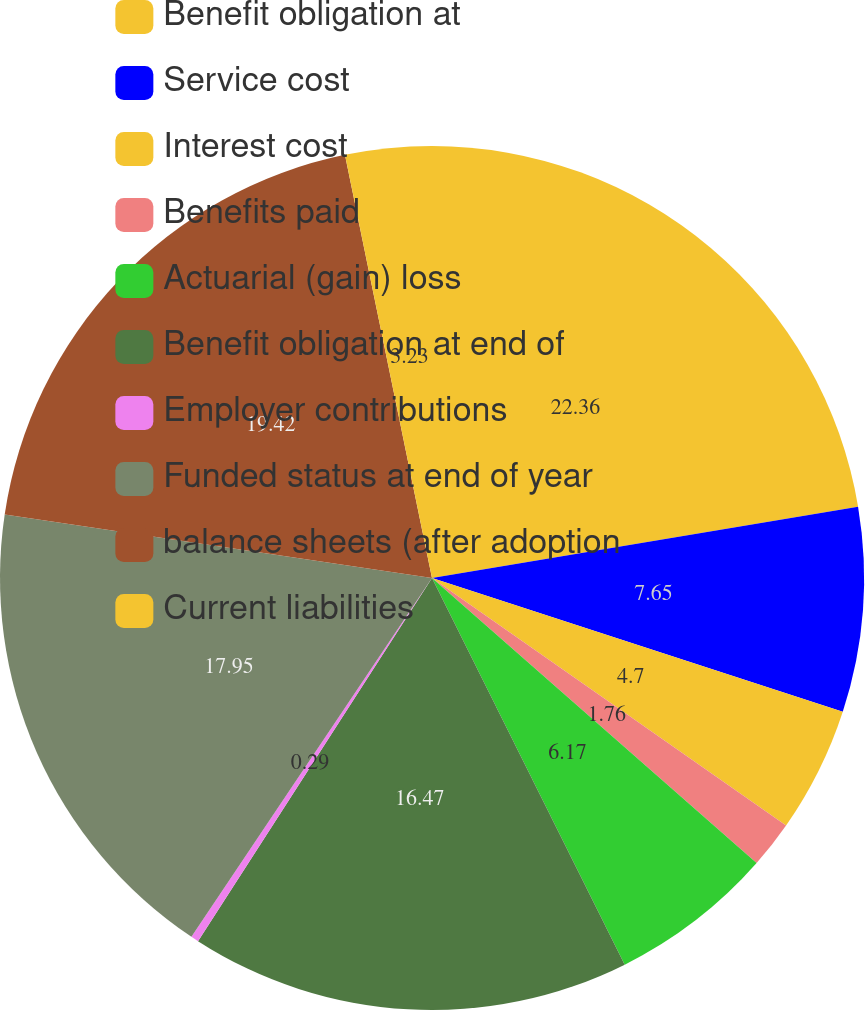Convert chart. <chart><loc_0><loc_0><loc_500><loc_500><pie_chart><fcel>Benefit obligation at<fcel>Service cost<fcel>Interest cost<fcel>Benefits paid<fcel>Actuarial (gain) loss<fcel>Benefit obligation at end of<fcel>Employer contributions<fcel>Funded status at end of year<fcel>balance sheets (after adoption<fcel>Current liabilities<nl><fcel>22.36%<fcel>7.65%<fcel>4.7%<fcel>1.76%<fcel>6.17%<fcel>16.47%<fcel>0.29%<fcel>17.95%<fcel>19.42%<fcel>3.23%<nl></chart> 